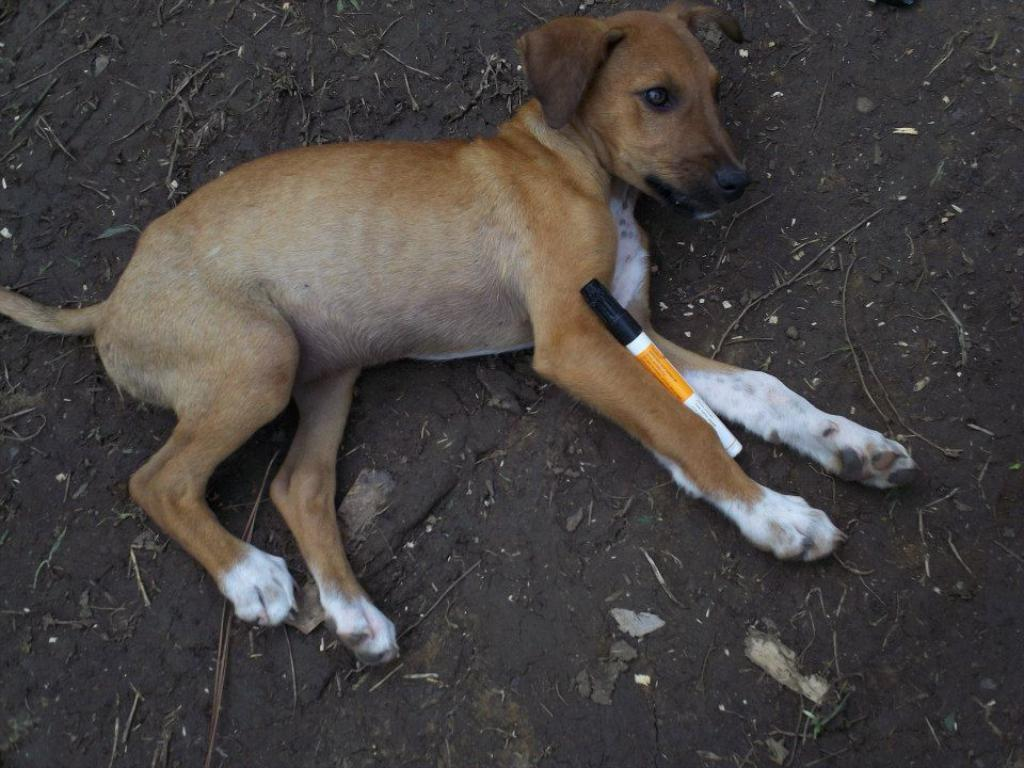What type of animal is present in the image? There is a dog in the image. What is the dog doing in the image? The dog is laying down. What object can be seen in the image besides the dog? There is a marker visible in the image. What type of surface is visible at the bottom of the image? There is soil visible at the bottom of the image. What type of prison can be seen in the image? There is no prison present in the image; it features a dog laying down, a marker, and soil. How many fangs does the dog have in the image? The image does not show the dog's teeth or fangs, so it cannot be determined from the image. 